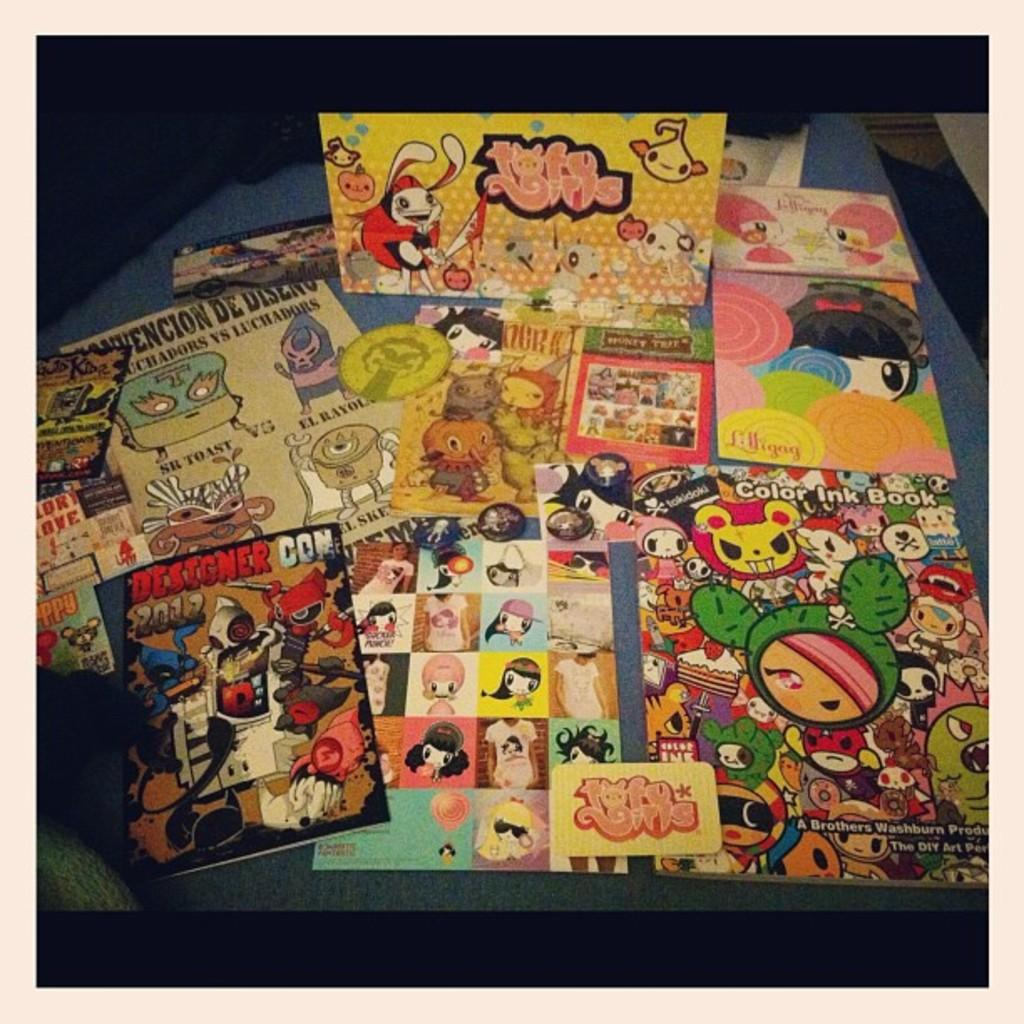<image>
Create a compact narrative representing the image presented. A table is covered in comic books and a magazine that says Color Ink Book. 